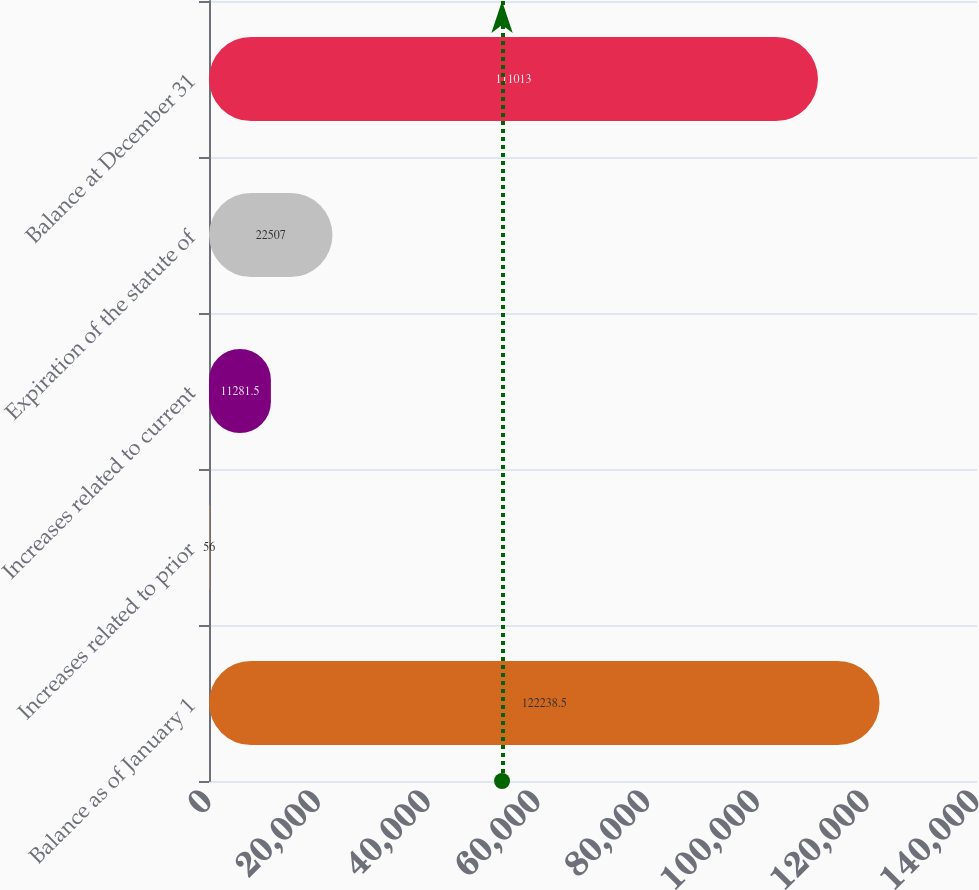Convert chart. <chart><loc_0><loc_0><loc_500><loc_500><bar_chart><fcel>Balance as of January 1<fcel>Increases related to prior<fcel>Increases related to current<fcel>Expiration of the statute of<fcel>Balance at December 31<nl><fcel>122238<fcel>56<fcel>11281.5<fcel>22507<fcel>111013<nl></chart> 